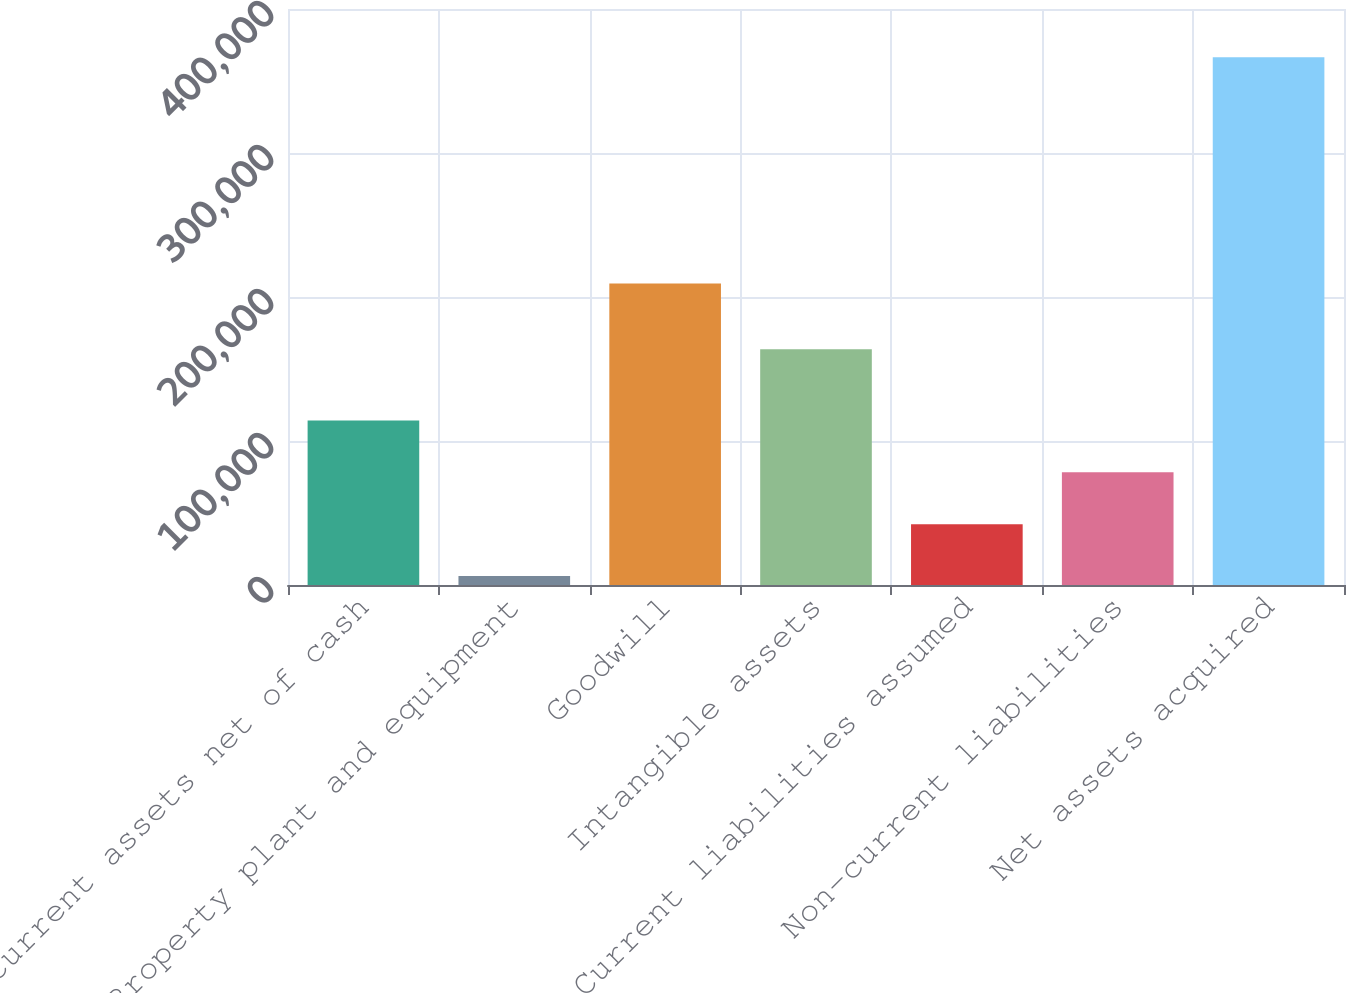<chart> <loc_0><loc_0><loc_500><loc_500><bar_chart><fcel>Current assets net of cash<fcel>Property plant and equipment<fcel>Goodwill<fcel>Intangible assets<fcel>Current liabilities assumed<fcel>Non-current liabilities<fcel>Net assets acquired<nl><fcel>114299<fcel>6199<fcel>209330<fcel>163727<fcel>42232.3<fcel>78265.6<fcel>366532<nl></chart> 